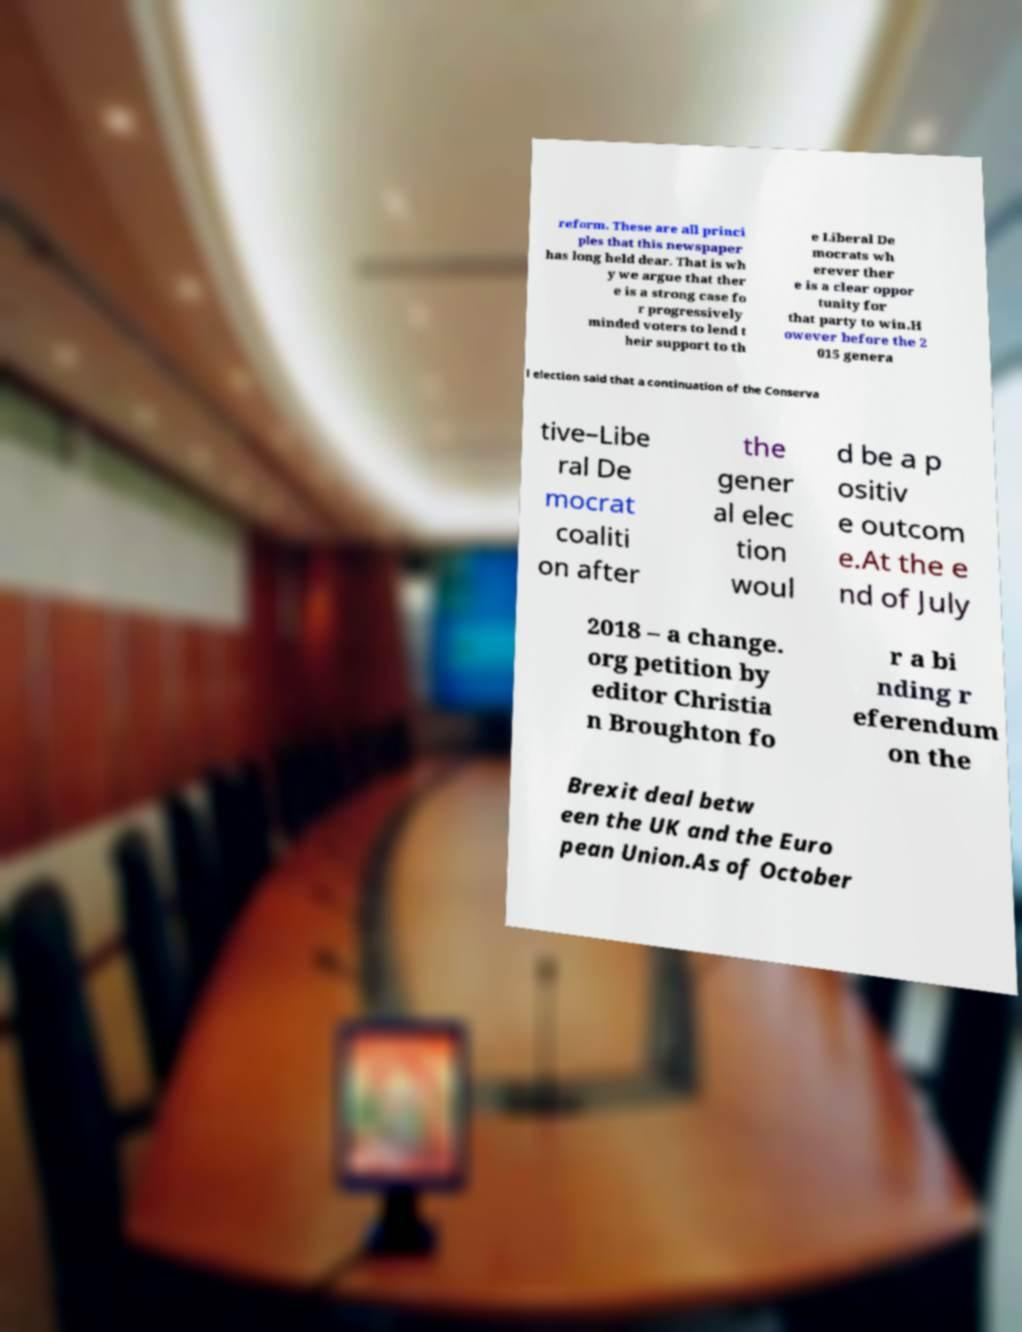Can you accurately transcribe the text from the provided image for me? reform. These are all princi ples that this newspaper has long held dear. That is wh y we argue that ther e is a strong case fo r progressively minded voters to lend t heir support to th e Liberal De mocrats wh erever ther e is a clear oppor tunity for that party to win.H owever before the 2 015 genera l election said that a continuation of the Conserva tive–Libe ral De mocrat coaliti on after the gener al elec tion woul d be a p ositiv e outcom e.At the e nd of July 2018 – a change. org petition by editor Christia n Broughton fo r a bi nding r eferendum on the Brexit deal betw een the UK and the Euro pean Union.As of October 